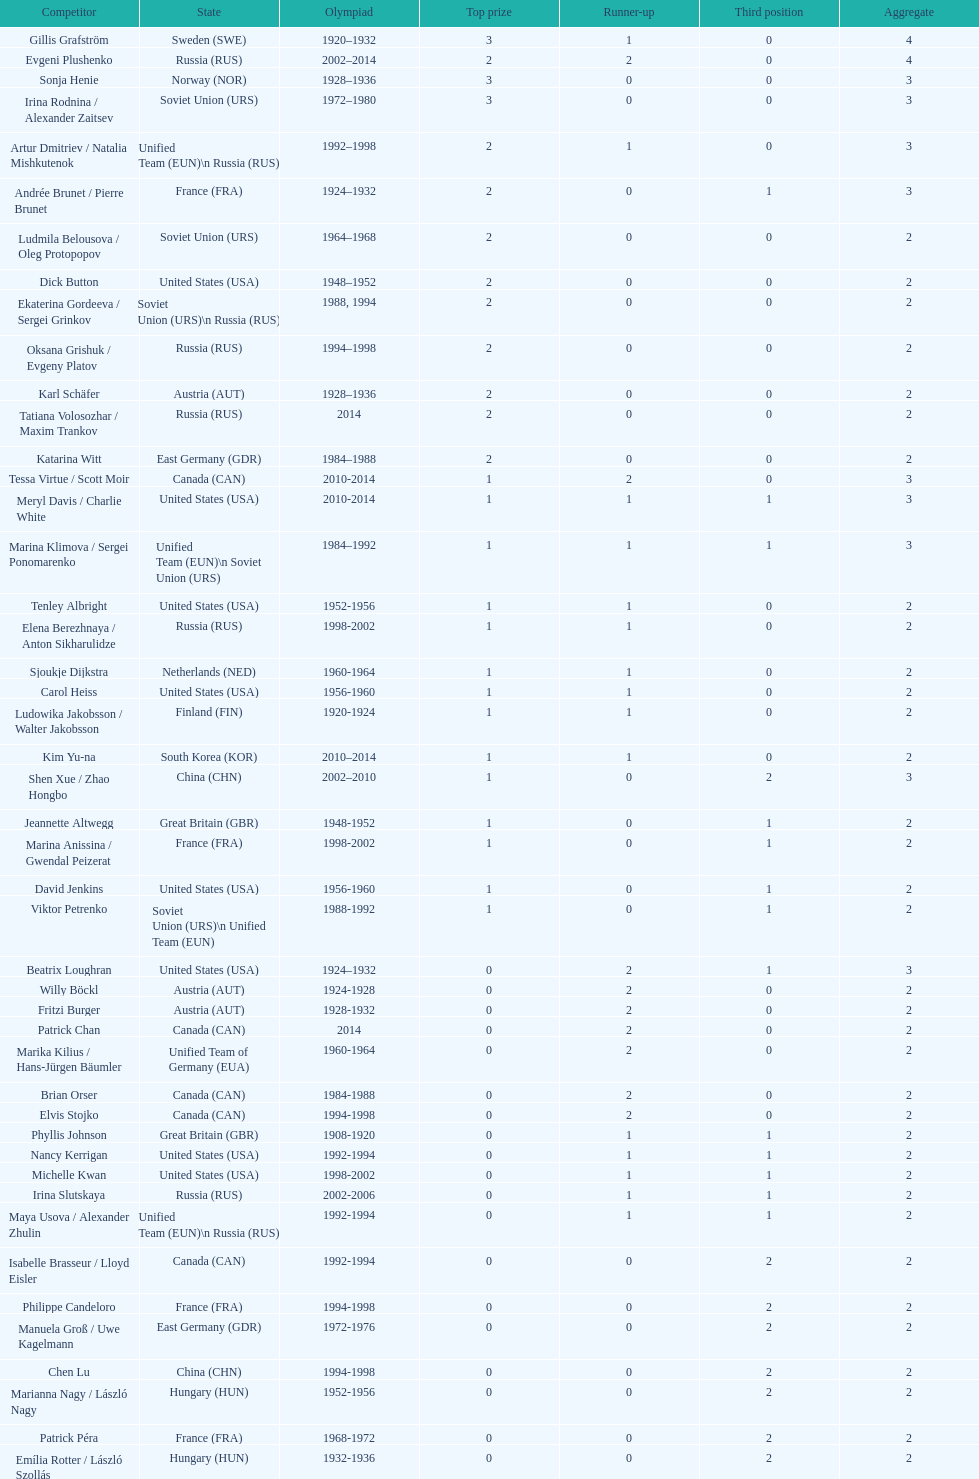How many silver medals did evgeni plushenko get? 2. 